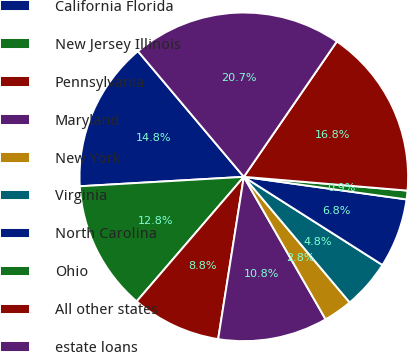Convert chart. <chart><loc_0><loc_0><loc_500><loc_500><pie_chart><fcel>California Florida<fcel>New Jersey Illinois<fcel>Pennsylvania<fcel>Maryland<fcel>New York<fcel>Virginia<fcel>North Carolina<fcel>Ohio<fcel>All other states<fcel>estate loans<nl><fcel>14.77%<fcel>12.78%<fcel>8.81%<fcel>10.79%<fcel>2.85%<fcel>4.84%<fcel>6.82%<fcel>0.86%<fcel>16.75%<fcel>20.73%<nl></chart> 